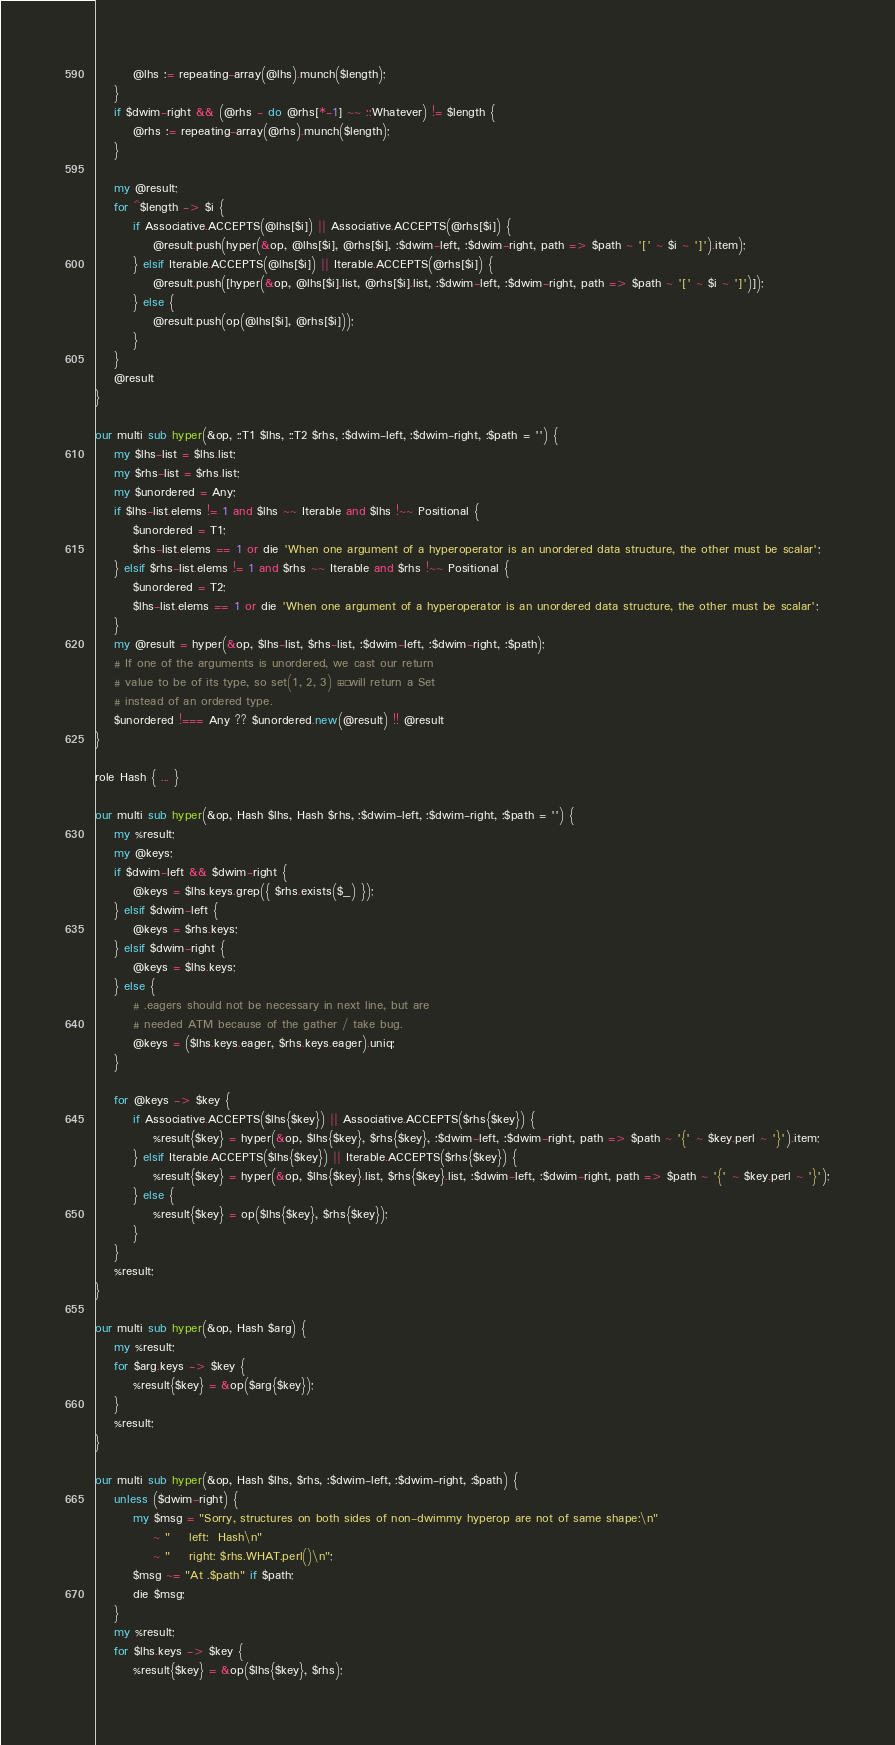Convert code to text. <code><loc_0><loc_0><loc_500><loc_500><_Perl_>        @lhs := repeating-array(@lhs).munch($length);
    }
    if $dwim-right && (@rhs - do @rhs[*-1] ~~ ::Whatever) != $length {
        @rhs := repeating-array(@rhs).munch($length);
    }

    my @result;
    for ^$length -> $i {
        if Associative.ACCEPTS(@lhs[$i]) || Associative.ACCEPTS(@rhs[$i]) {
            @result.push(hyper(&op, @lhs[$i], @rhs[$i], :$dwim-left, :$dwim-right, path => $path ~ '[' ~ $i ~ ']').item);
        } elsif Iterable.ACCEPTS(@lhs[$i]) || Iterable.ACCEPTS(@rhs[$i]) {
            @result.push([hyper(&op, @lhs[$i].list, @rhs[$i].list, :$dwim-left, :$dwim-right, path => $path ~ '[' ~ $i ~ ']')]);
        } else {
            @result.push(op(@lhs[$i], @rhs[$i]));
        }
    }
    @result
}

our multi sub hyper(&op, ::T1 $lhs, ::T2 $rhs, :$dwim-left, :$dwim-right, :$path = '') {
    my $lhs-list = $lhs.list;
    my $rhs-list = $rhs.list;
    my $unordered = Any;
    if $lhs-list.elems != 1 and $lhs ~~ Iterable and $lhs !~~ Positional {
        $unordered = T1;
        $rhs-list.elems == 1 or die 'When one argument of a hyperoperator is an unordered data structure, the other must be scalar';
    } elsif $rhs-list.elems != 1 and $rhs ~~ Iterable and $rhs !~~ Positional {
        $unordered = T2;
        $lhs-list.elems == 1 or die 'When one argument of a hyperoperator is an unordered data structure, the other must be scalar';
    }
    my @result = hyper(&op, $lhs-list, $rhs-list, :$dwim-left, :$dwim-right, :$path);
    # If one of the arguments is unordered, we cast our return
    # value to be of its type, so set(1, 2, 3) »+» will return a Set
    # instead of an ordered type.
    $unordered !=== Any ?? $unordered.new(@result) !! @result
}

role Hash { ... }

our multi sub hyper(&op, Hash $lhs, Hash $rhs, :$dwim-left, :$dwim-right, :$path = '') {
    my %result;
    my @keys;
    if $dwim-left && $dwim-right {
        @keys = $lhs.keys.grep({ $rhs.exists($_) });
    } elsif $dwim-left {
        @keys = $rhs.keys;
    } elsif $dwim-right {
        @keys = $lhs.keys;
    } else {
        # .eagers should not be necessary in next line, but are
        # needed ATM because of the gather / take bug.
        @keys = ($lhs.keys.eager, $rhs.keys.eager).uniq;
    }

    for @keys -> $key {
        if Associative.ACCEPTS($lhs{$key}) || Associative.ACCEPTS($rhs{$key}) {
            %result{$key} = hyper(&op, $lhs{$key}, $rhs{$key}, :$dwim-left, :$dwim-right, path => $path ~ '{' ~ $key.perl ~ '}').item;
        } elsif Iterable.ACCEPTS($lhs{$key}) || Iterable.ACCEPTS($rhs{$key}) {
            %result{$key} = hyper(&op, $lhs{$key}.list, $rhs{$key}.list, :$dwim-left, :$dwim-right, path => $path ~ '{' ~ $key.perl ~ '}');
        } else {
            %result{$key} = op($lhs{$key}, $rhs{$key});
        }
    }
    %result;
}

our multi sub hyper(&op, Hash $arg) {
    my %result;
    for $arg.keys -> $key {
        %result{$key} = &op($arg{$key});
    }
    %result;
}

our multi sub hyper(&op, Hash $lhs, $rhs, :$dwim-left, :$dwim-right, :$path) {
    unless ($dwim-right) {
        my $msg = "Sorry, structures on both sides of non-dwimmy hyperop are not of same shape:\n"
            ~ "    left:  Hash\n"
            ~ "    right: $rhs.WHAT.perl()\n";
        $msg ~= "At .$path" if $path;
        die $msg;
    }
    my %result;
    for $lhs.keys -> $key {
        %result{$key} = &op($lhs{$key}, $rhs);</code> 